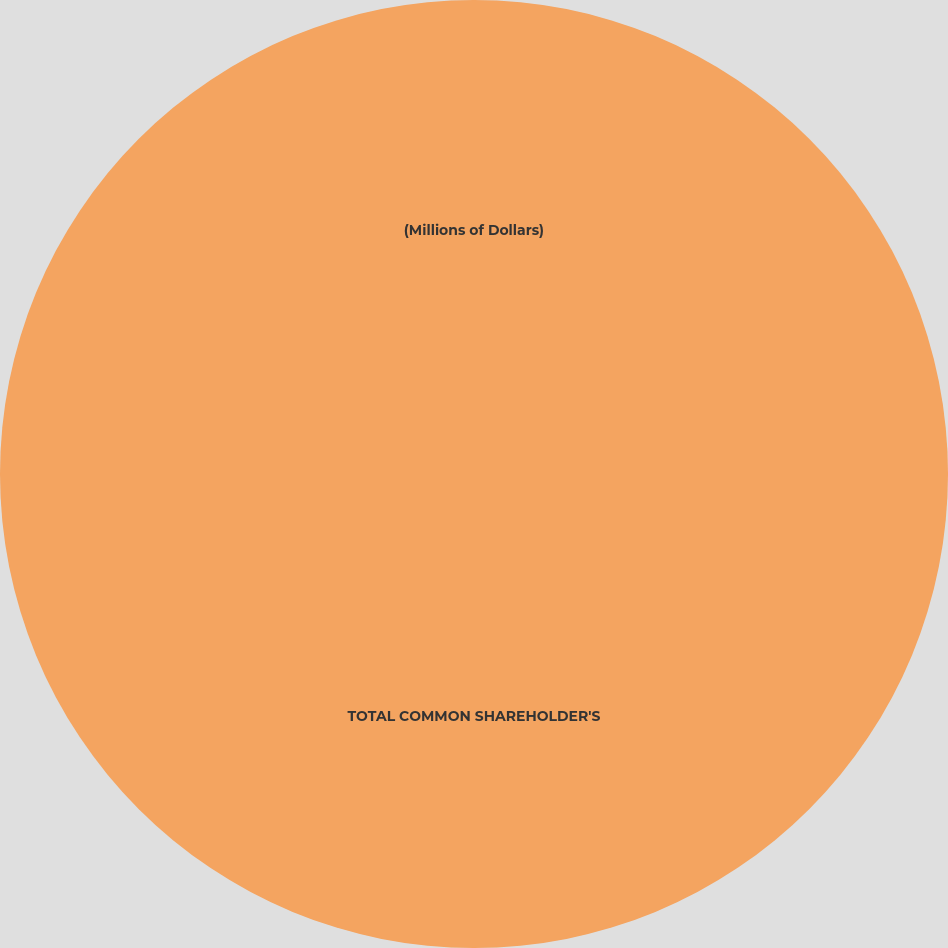Convert chart to OTSL. <chart><loc_0><loc_0><loc_500><loc_500><pie_chart><fcel>(Millions of Dollars)<fcel>TOTAL COMMON SHAREHOLDER'S<nl><fcel>0.0%<fcel>100.0%<nl></chart> 